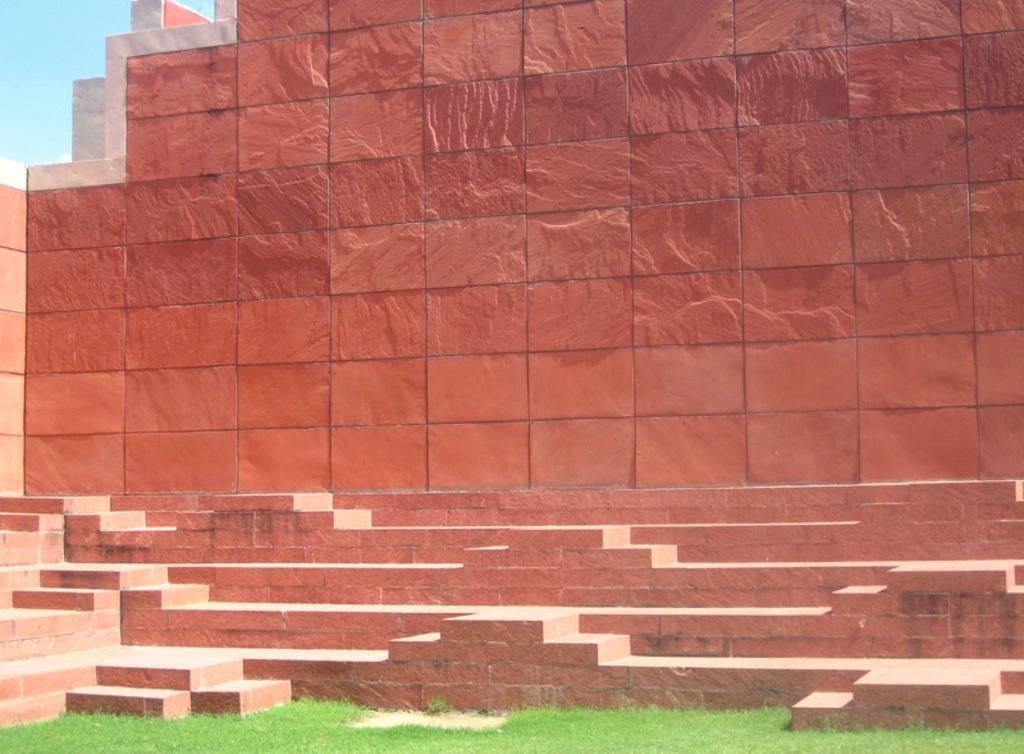What is one of the main features of the image? There is a wall in the image. What type of vegetation can be seen on the ground in the image? There is green grass on the ground in the image. What type of oatmeal is being served on the wall in the image? There is no oatmeal present in the image; it only features a wall and green grass on the ground. How does the clock on the wall affect the image? There is no clock present in the image, so its effect cannot be determined. 